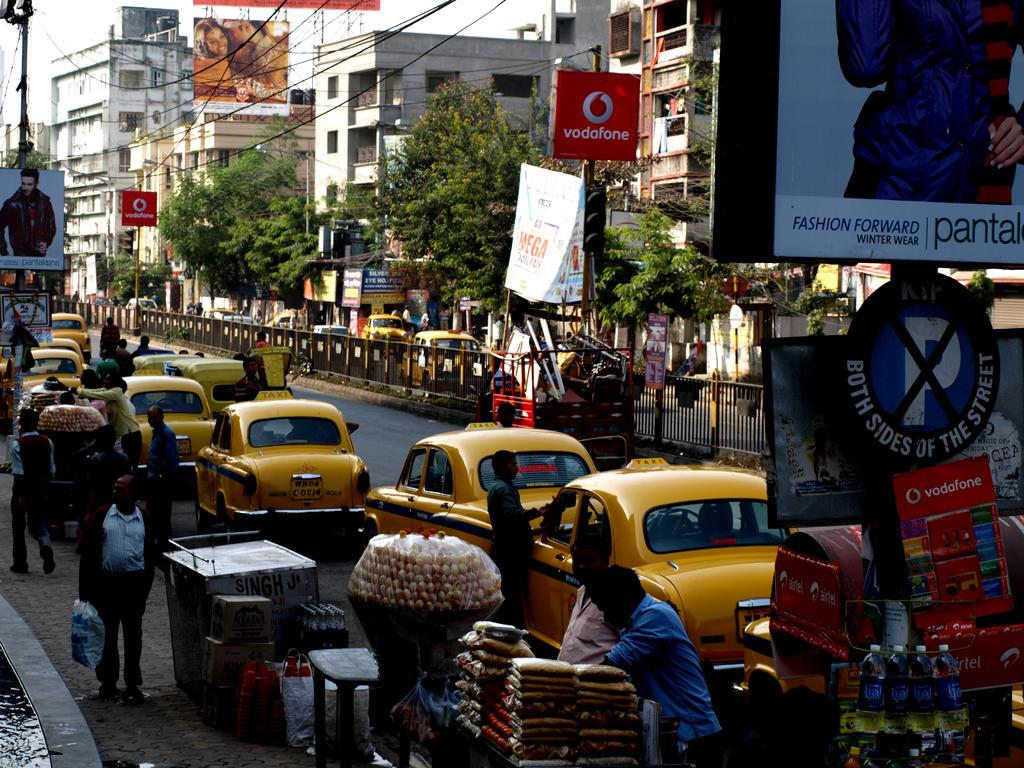<image>
Summarize the visual content of the image. a line of taxi cabs alongside a vodafone street sign 